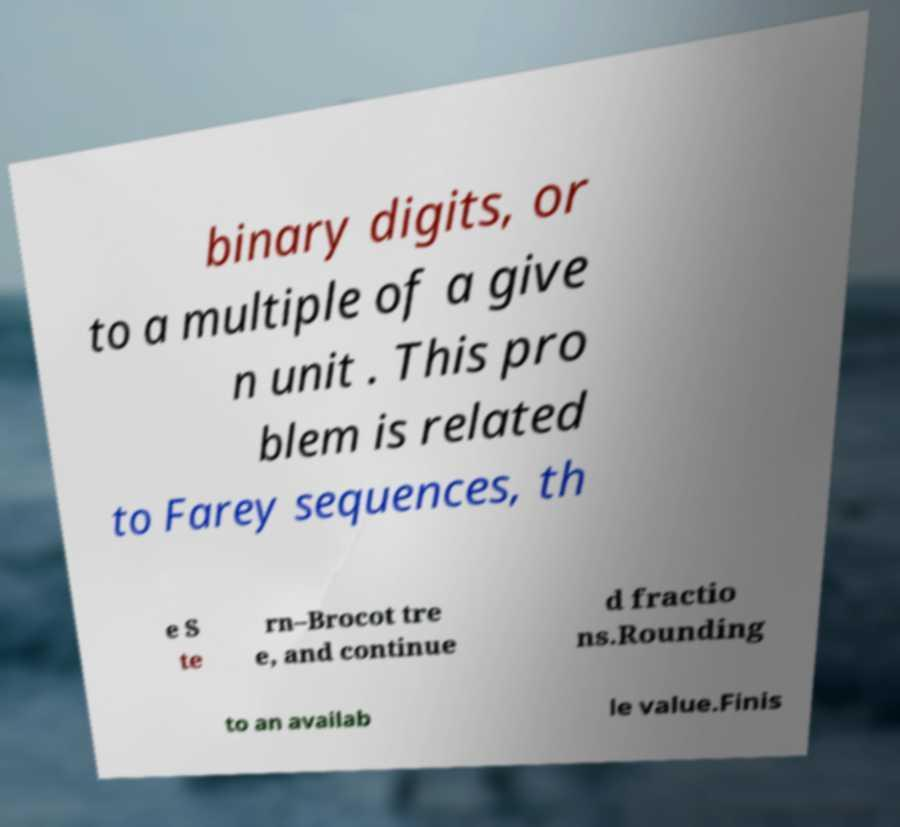For documentation purposes, I need the text within this image transcribed. Could you provide that? binary digits, or to a multiple of a give n unit . This pro blem is related to Farey sequences, th e S te rn–Brocot tre e, and continue d fractio ns.Rounding to an availab le value.Finis 